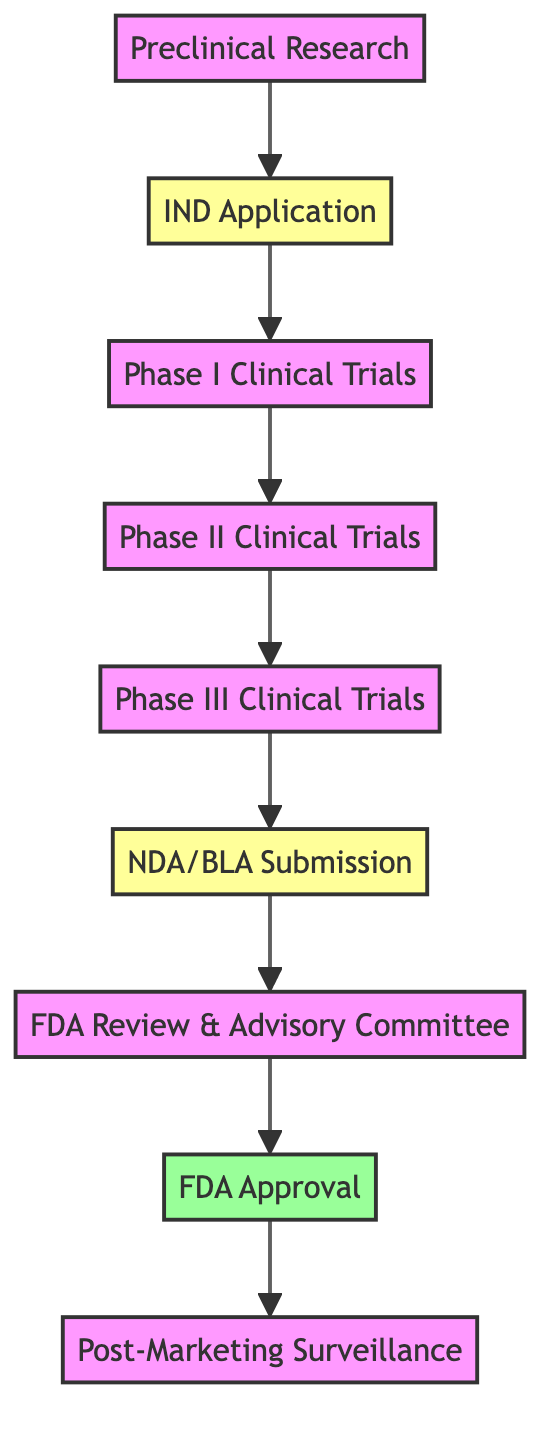What is the first step in the diagram? The first node in the flowchart is "Preclinical Research," which signifies the initial phase of the regulatory submission process.
Answer: Preclinical Research How many phases of clinical trials are present in the workflow? The diagram outlines three distinct phases of clinical trials: Phase I, Phase II, and Phase III. Therefore, the total is three.
Answer: 3 What step follows the IND Application? After the IND Application, the next step in the sequence of the diagram is "Phase I Clinical Trials." This indicates that the sequential process continues from the IND submission to the first phase of human trials.
Answer: Phase I Clinical Trials Which step leads directly to FDA Approval? The step that leads directly to FDA Approval is "FDA Review & Advisory Committee." This step occurs after the NDA/BLA submission and is a prerequisite for obtaining approval from the FDA.
Answer: FDA Review & Advisory Committee What is the last step in the workflow? The last step in the flowchart is "Post-Marketing Surveillance." It follows FDA Approval, indicating the ongoing monitoring of the drug's performance in the market.
Answer: Post-Marketing Surveillance How many submissions are made in the entire workflow? There are two submissions made in the workflow: the IND Application and the NDA/BLA Submission. This indicates that submissions occur at the start and near the end of the workflow.
Answer: 2 What is the purpose of the FDA Review & Advisory Committee step? The purpose of the FDA Review & Advisory Committee step is to review the application, allowing an independent advisory committee to recommend whether the drug should be approved. This shows the vital role this step plays in the approval process.
Answer: Review application What follows after Phase III Clinical Trials? After Phase III Clinical Trials, the next step outlined in the diagram is the "NDA/BLA Submission." This step is crucial as it is where the gathered research data is formally submitted to the FDA for review.
Answer: NDA/BLA Submission In terms of structure, how many nodes are in this workflow diagram? The structure of the diagram consists of nine distinct nodes representing various steps in the regulatory submission workflow from preclinical research to post-marketing surveillance.
Answer: 9 